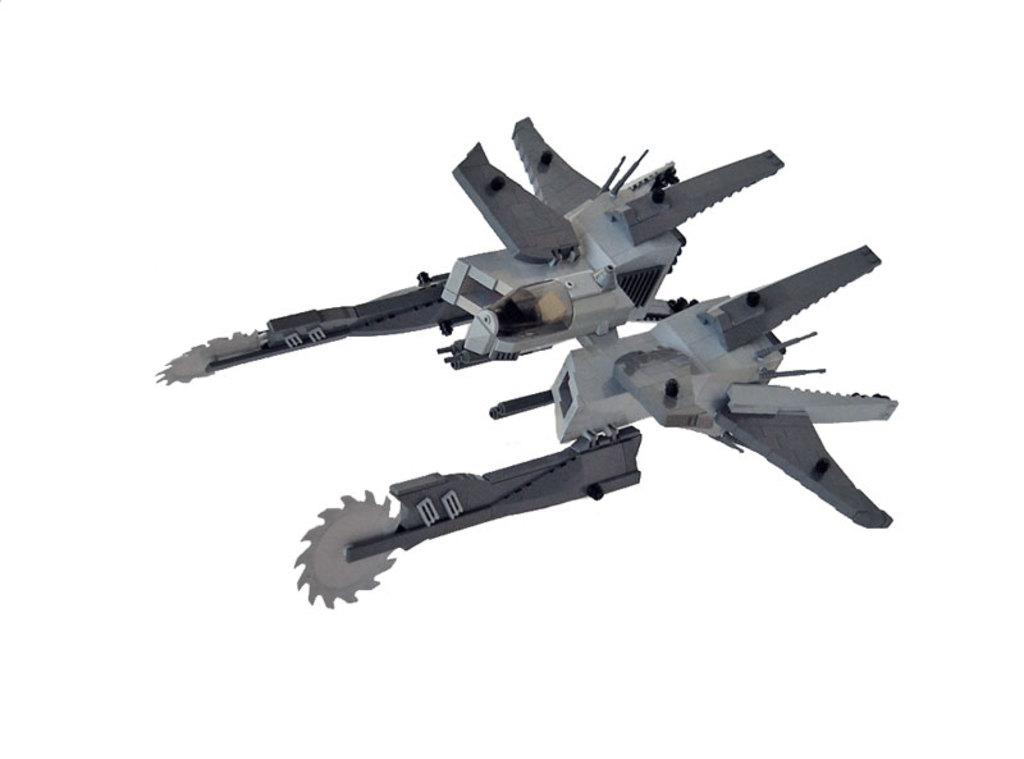What object can be seen in the image? There is a toy in the image. What color is the background of the image? The background of the image is white. What type of dress is the toy wearing in the image? The toy does not have a dress, as it is not a person or an object that typically wears clothing. 